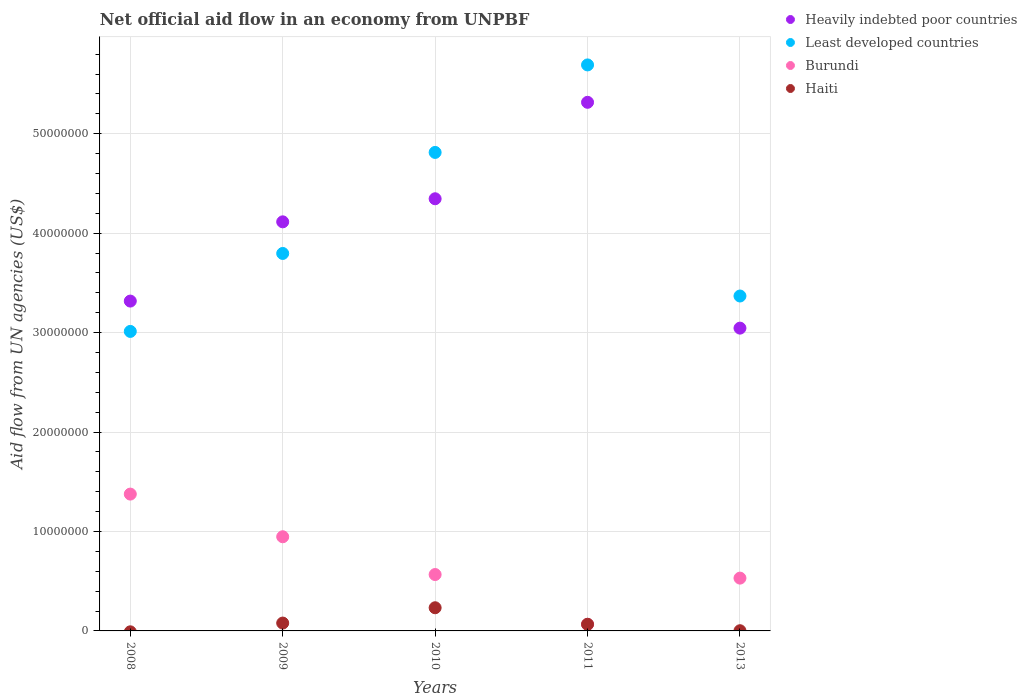How many different coloured dotlines are there?
Provide a short and direct response. 4. Is the number of dotlines equal to the number of legend labels?
Offer a terse response. No. What is the net official aid flow in Least developed countries in 2010?
Make the answer very short. 4.81e+07. Across all years, what is the maximum net official aid flow in Heavily indebted poor countries?
Ensure brevity in your answer.  5.32e+07. Across all years, what is the minimum net official aid flow in Heavily indebted poor countries?
Your response must be concise. 3.04e+07. What is the total net official aid flow in Burundi in the graph?
Make the answer very short. 3.49e+07. What is the difference between the net official aid flow in Least developed countries in 2010 and that in 2013?
Provide a succinct answer. 1.44e+07. What is the difference between the net official aid flow in Least developed countries in 2013 and the net official aid flow in Heavily indebted poor countries in 2009?
Your answer should be very brief. -7.46e+06. What is the average net official aid flow in Burundi per year?
Your answer should be compact. 6.97e+06. In the year 2009, what is the difference between the net official aid flow in Least developed countries and net official aid flow in Heavily indebted poor countries?
Keep it short and to the point. -3.18e+06. What is the ratio of the net official aid flow in Heavily indebted poor countries in 2010 to that in 2013?
Make the answer very short. 1.43. What is the difference between the highest and the second highest net official aid flow in Heavily indebted poor countries?
Give a very brief answer. 9.70e+06. What is the difference between the highest and the lowest net official aid flow in Haiti?
Your answer should be compact. 2.33e+06. Is it the case that in every year, the sum of the net official aid flow in Haiti and net official aid flow in Heavily indebted poor countries  is greater than the net official aid flow in Burundi?
Offer a terse response. Yes. Does the net official aid flow in Haiti monotonically increase over the years?
Offer a very short reply. No. How many years are there in the graph?
Your answer should be very brief. 5. Are the values on the major ticks of Y-axis written in scientific E-notation?
Make the answer very short. No. Does the graph contain any zero values?
Your answer should be very brief. Yes. Does the graph contain grids?
Your answer should be compact. Yes. How are the legend labels stacked?
Keep it short and to the point. Vertical. What is the title of the graph?
Keep it short and to the point. Net official aid flow in an economy from UNPBF. Does "Uganda" appear as one of the legend labels in the graph?
Your answer should be compact. No. What is the label or title of the Y-axis?
Give a very brief answer. Aid flow from UN agencies (US$). What is the Aid flow from UN agencies (US$) in Heavily indebted poor countries in 2008?
Give a very brief answer. 3.32e+07. What is the Aid flow from UN agencies (US$) in Least developed countries in 2008?
Provide a short and direct response. 3.01e+07. What is the Aid flow from UN agencies (US$) of Burundi in 2008?
Provide a succinct answer. 1.38e+07. What is the Aid flow from UN agencies (US$) of Heavily indebted poor countries in 2009?
Keep it short and to the point. 4.11e+07. What is the Aid flow from UN agencies (US$) in Least developed countries in 2009?
Keep it short and to the point. 3.80e+07. What is the Aid flow from UN agencies (US$) of Burundi in 2009?
Your answer should be compact. 9.47e+06. What is the Aid flow from UN agencies (US$) of Haiti in 2009?
Offer a terse response. 7.90e+05. What is the Aid flow from UN agencies (US$) in Heavily indebted poor countries in 2010?
Provide a short and direct response. 4.35e+07. What is the Aid flow from UN agencies (US$) in Least developed countries in 2010?
Your answer should be very brief. 4.81e+07. What is the Aid flow from UN agencies (US$) of Burundi in 2010?
Make the answer very short. 5.67e+06. What is the Aid flow from UN agencies (US$) in Haiti in 2010?
Give a very brief answer. 2.33e+06. What is the Aid flow from UN agencies (US$) in Heavily indebted poor countries in 2011?
Your answer should be very brief. 5.32e+07. What is the Aid flow from UN agencies (US$) of Least developed countries in 2011?
Your answer should be compact. 5.69e+07. What is the Aid flow from UN agencies (US$) in Burundi in 2011?
Keep it short and to the point. 6.60e+05. What is the Aid flow from UN agencies (US$) in Haiti in 2011?
Your answer should be very brief. 6.70e+05. What is the Aid flow from UN agencies (US$) of Heavily indebted poor countries in 2013?
Your answer should be very brief. 3.04e+07. What is the Aid flow from UN agencies (US$) of Least developed countries in 2013?
Give a very brief answer. 3.37e+07. What is the Aid flow from UN agencies (US$) in Burundi in 2013?
Your answer should be very brief. 5.31e+06. Across all years, what is the maximum Aid flow from UN agencies (US$) of Heavily indebted poor countries?
Your answer should be compact. 5.32e+07. Across all years, what is the maximum Aid flow from UN agencies (US$) in Least developed countries?
Your answer should be very brief. 5.69e+07. Across all years, what is the maximum Aid flow from UN agencies (US$) of Burundi?
Offer a terse response. 1.38e+07. Across all years, what is the maximum Aid flow from UN agencies (US$) in Haiti?
Offer a terse response. 2.33e+06. Across all years, what is the minimum Aid flow from UN agencies (US$) in Heavily indebted poor countries?
Offer a very short reply. 3.04e+07. Across all years, what is the minimum Aid flow from UN agencies (US$) in Least developed countries?
Your answer should be compact. 3.01e+07. Across all years, what is the minimum Aid flow from UN agencies (US$) of Burundi?
Your answer should be very brief. 6.60e+05. What is the total Aid flow from UN agencies (US$) of Heavily indebted poor countries in the graph?
Your answer should be very brief. 2.01e+08. What is the total Aid flow from UN agencies (US$) of Least developed countries in the graph?
Give a very brief answer. 2.07e+08. What is the total Aid flow from UN agencies (US$) in Burundi in the graph?
Your answer should be compact. 3.49e+07. What is the total Aid flow from UN agencies (US$) in Haiti in the graph?
Provide a short and direct response. 3.81e+06. What is the difference between the Aid flow from UN agencies (US$) of Heavily indebted poor countries in 2008 and that in 2009?
Give a very brief answer. -7.97e+06. What is the difference between the Aid flow from UN agencies (US$) of Least developed countries in 2008 and that in 2009?
Your answer should be compact. -7.84e+06. What is the difference between the Aid flow from UN agencies (US$) in Burundi in 2008 and that in 2009?
Your answer should be compact. 4.29e+06. What is the difference between the Aid flow from UN agencies (US$) in Heavily indebted poor countries in 2008 and that in 2010?
Provide a succinct answer. -1.03e+07. What is the difference between the Aid flow from UN agencies (US$) in Least developed countries in 2008 and that in 2010?
Make the answer very short. -1.80e+07. What is the difference between the Aid flow from UN agencies (US$) of Burundi in 2008 and that in 2010?
Give a very brief answer. 8.09e+06. What is the difference between the Aid flow from UN agencies (US$) in Heavily indebted poor countries in 2008 and that in 2011?
Offer a terse response. -2.00e+07. What is the difference between the Aid flow from UN agencies (US$) in Least developed countries in 2008 and that in 2011?
Offer a very short reply. -2.68e+07. What is the difference between the Aid flow from UN agencies (US$) of Burundi in 2008 and that in 2011?
Your response must be concise. 1.31e+07. What is the difference between the Aid flow from UN agencies (US$) of Heavily indebted poor countries in 2008 and that in 2013?
Offer a very short reply. 2.72e+06. What is the difference between the Aid flow from UN agencies (US$) in Least developed countries in 2008 and that in 2013?
Offer a terse response. -3.56e+06. What is the difference between the Aid flow from UN agencies (US$) in Burundi in 2008 and that in 2013?
Your response must be concise. 8.45e+06. What is the difference between the Aid flow from UN agencies (US$) of Heavily indebted poor countries in 2009 and that in 2010?
Offer a very short reply. -2.32e+06. What is the difference between the Aid flow from UN agencies (US$) of Least developed countries in 2009 and that in 2010?
Ensure brevity in your answer.  -1.02e+07. What is the difference between the Aid flow from UN agencies (US$) of Burundi in 2009 and that in 2010?
Provide a short and direct response. 3.80e+06. What is the difference between the Aid flow from UN agencies (US$) in Haiti in 2009 and that in 2010?
Give a very brief answer. -1.54e+06. What is the difference between the Aid flow from UN agencies (US$) of Heavily indebted poor countries in 2009 and that in 2011?
Ensure brevity in your answer.  -1.20e+07. What is the difference between the Aid flow from UN agencies (US$) in Least developed countries in 2009 and that in 2011?
Provide a succinct answer. -1.90e+07. What is the difference between the Aid flow from UN agencies (US$) of Burundi in 2009 and that in 2011?
Make the answer very short. 8.81e+06. What is the difference between the Aid flow from UN agencies (US$) of Haiti in 2009 and that in 2011?
Your answer should be compact. 1.20e+05. What is the difference between the Aid flow from UN agencies (US$) of Heavily indebted poor countries in 2009 and that in 2013?
Make the answer very short. 1.07e+07. What is the difference between the Aid flow from UN agencies (US$) in Least developed countries in 2009 and that in 2013?
Your answer should be compact. 4.28e+06. What is the difference between the Aid flow from UN agencies (US$) of Burundi in 2009 and that in 2013?
Provide a succinct answer. 4.16e+06. What is the difference between the Aid flow from UN agencies (US$) of Haiti in 2009 and that in 2013?
Make the answer very short. 7.70e+05. What is the difference between the Aid flow from UN agencies (US$) of Heavily indebted poor countries in 2010 and that in 2011?
Ensure brevity in your answer.  -9.70e+06. What is the difference between the Aid flow from UN agencies (US$) in Least developed countries in 2010 and that in 2011?
Provide a short and direct response. -8.80e+06. What is the difference between the Aid flow from UN agencies (US$) in Burundi in 2010 and that in 2011?
Provide a succinct answer. 5.01e+06. What is the difference between the Aid flow from UN agencies (US$) of Haiti in 2010 and that in 2011?
Your response must be concise. 1.66e+06. What is the difference between the Aid flow from UN agencies (US$) of Heavily indebted poor countries in 2010 and that in 2013?
Keep it short and to the point. 1.30e+07. What is the difference between the Aid flow from UN agencies (US$) in Least developed countries in 2010 and that in 2013?
Your response must be concise. 1.44e+07. What is the difference between the Aid flow from UN agencies (US$) in Burundi in 2010 and that in 2013?
Provide a succinct answer. 3.60e+05. What is the difference between the Aid flow from UN agencies (US$) in Haiti in 2010 and that in 2013?
Ensure brevity in your answer.  2.31e+06. What is the difference between the Aid flow from UN agencies (US$) of Heavily indebted poor countries in 2011 and that in 2013?
Make the answer very short. 2.27e+07. What is the difference between the Aid flow from UN agencies (US$) of Least developed countries in 2011 and that in 2013?
Provide a succinct answer. 2.32e+07. What is the difference between the Aid flow from UN agencies (US$) of Burundi in 2011 and that in 2013?
Make the answer very short. -4.65e+06. What is the difference between the Aid flow from UN agencies (US$) of Haiti in 2011 and that in 2013?
Your answer should be very brief. 6.50e+05. What is the difference between the Aid flow from UN agencies (US$) of Heavily indebted poor countries in 2008 and the Aid flow from UN agencies (US$) of Least developed countries in 2009?
Your response must be concise. -4.79e+06. What is the difference between the Aid flow from UN agencies (US$) of Heavily indebted poor countries in 2008 and the Aid flow from UN agencies (US$) of Burundi in 2009?
Make the answer very short. 2.37e+07. What is the difference between the Aid flow from UN agencies (US$) in Heavily indebted poor countries in 2008 and the Aid flow from UN agencies (US$) in Haiti in 2009?
Give a very brief answer. 3.24e+07. What is the difference between the Aid flow from UN agencies (US$) in Least developed countries in 2008 and the Aid flow from UN agencies (US$) in Burundi in 2009?
Your answer should be compact. 2.06e+07. What is the difference between the Aid flow from UN agencies (US$) in Least developed countries in 2008 and the Aid flow from UN agencies (US$) in Haiti in 2009?
Your answer should be compact. 2.93e+07. What is the difference between the Aid flow from UN agencies (US$) in Burundi in 2008 and the Aid flow from UN agencies (US$) in Haiti in 2009?
Give a very brief answer. 1.30e+07. What is the difference between the Aid flow from UN agencies (US$) in Heavily indebted poor countries in 2008 and the Aid flow from UN agencies (US$) in Least developed countries in 2010?
Provide a short and direct response. -1.50e+07. What is the difference between the Aid flow from UN agencies (US$) in Heavily indebted poor countries in 2008 and the Aid flow from UN agencies (US$) in Burundi in 2010?
Provide a short and direct response. 2.75e+07. What is the difference between the Aid flow from UN agencies (US$) in Heavily indebted poor countries in 2008 and the Aid flow from UN agencies (US$) in Haiti in 2010?
Ensure brevity in your answer.  3.08e+07. What is the difference between the Aid flow from UN agencies (US$) of Least developed countries in 2008 and the Aid flow from UN agencies (US$) of Burundi in 2010?
Give a very brief answer. 2.44e+07. What is the difference between the Aid flow from UN agencies (US$) in Least developed countries in 2008 and the Aid flow from UN agencies (US$) in Haiti in 2010?
Keep it short and to the point. 2.78e+07. What is the difference between the Aid flow from UN agencies (US$) of Burundi in 2008 and the Aid flow from UN agencies (US$) of Haiti in 2010?
Provide a short and direct response. 1.14e+07. What is the difference between the Aid flow from UN agencies (US$) of Heavily indebted poor countries in 2008 and the Aid flow from UN agencies (US$) of Least developed countries in 2011?
Your answer should be compact. -2.38e+07. What is the difference between the Aid flow from UN agencies (US$) in Heavily indebted poor countries in 2008 and the Aid flow from UN agencies (US$) in Burundi in 2011?
Your response must be concise. 3.25e+07. What is the difference between the Aid flow from UN agencies (US$) of Heavily indebted poor countries in 2008 and the Aid flow from UN agencies (US$) of Haiti in 2011?
Provide a short and direct response. 3.25e+07. What is the difference between the Aid flow from UN agencies (US$) of Least developed countries in 2008 and the Aid flow from UN agencies (US$) of Burundi in 2011?
Your answer should be very brief. 2.95e+07. What is the difference between the Aid flow from UN agencies (US$) of Least developed countries in 2008 and the Aid flow from UN agencies (US$) of Haiti in 2011?
Your response must be concise. 2.94e+07. What is the difference between the Aid flow from UN agencies (US$) of Burundi in 2008 and the Aid flow from UN agencies (US$) of Haiti in 2011?
Ensure brevity in your answer.  1.31e+07. What is the difference between the Aid flow from UN agencies (US$) of Heavily indebted poor countries in 2008 and the Aid flow from UN agencies (US$) of Least developed countries in 2013?
Your answer should be very brief. -5.10e+05. What is the difference between the Aid flow from UN agencies (US$) in Heavily indebted poor countries in 2008 and the Aid flow from UN agencies (US$) in Burundi in 2013?
Make the answer very short. 2.79e+07. What is the difference between the Aid flow from UN agencies (US$) of Heavily indebted poor countries in 2008 and the Aid flow from UN agencies (US$) of Haiti in 2013?
Keep it short and to the point. 3.32e+07. What is the difference between the Aid flow from UN agencies (US$) in Least developed countries in 2008 and the Aid flow from UN agencies (US$) in Burundi in 2013?
Your answer should be very brief. 2.48e+07. What is the difference between the Aid flow from UN agencies (US$) of Least developed countries in 2008 and the Aid flow from UN agencies (US$) of Haiti in 2013?
Offer a terse response. 3.01e+07. What is the difference between the Aid flow from UN agencies (US$) of Burundi in 2008 and the Aid flow from UN agencies (US$) of Haiti in 2013?
Offer a very short reply. 1.37e+07. What is the difference between the Aid flow from UN agencies (US$) in Heavily indebted poor countries in 2009 and the Aid flow from UN agencies (US$) in Least developed countries in 2010?
Ensure brevity in your answer.  -6.98e+06. What is the difference between the Aid flow from UN agencies (US$) of Heavily indebted poor countries in 2009 and the Aid flow from UN agencies (US$) of Burundi in 2010?
Provide a succinct answer. 3.55e+07. What is the difference between the Aid flow from UN agencies (US$) in Heavily indebted poor countries in 2009 and the Aid flow from UN agencies (US$) in Haiti in 2010?
Offer a very short reply. 3.88e+07. What is the difference between the Aid flow from UN agencies (US$) of Least developed countries in 2009 and the Aid flow from UN agencies (US$) of Burundi in 2010?
Make the answer very short. 3.23e+07. What is the difference between the Aid flow from UN agencies (US$) in Least developed countries in 2009 and the Aid flow from UN agencies (US$) in Haiti in 2010?
Provide a succinct answer. 3.56e+07. What is the difference between the Aid flow from UN agencies (US$) of Burundi in 2009 and the Aid flow from UN agencies (US$) of Haiti in 2010?
Make the answer very short. 7.14e+06. What is the difference between the Aid flow from UN agencies (US$) of Heavily indebted poor countries in 2009 and the Aid flow from UN agencies (US$) of Least developed countries in 2011?
Make the answer very short. -1.58e+07. What is the difference between the Aid flow from UN agencies (US$) of Heavily indebted poor countries in 2009 and the Aid flow from UN agencies (US$) of Burundi in 2011?
Make the answer very short. 4.05e+07. What is the difference between the Aid flow from UN agencies (US$) of Heavily indebted poor countries in 2009 and the Aid flow from UN agencies (US$) of Haiti in 2011?
Offer a terse response. 4.05e+07. What is the difference between the Aid flow from UN agencies (US$) of Least developed countries in 2009 and the Aid flow from UN agencies (US$) of Burundi in 2011?
Keep it short and to the point. 3.73e+07. What is the difference between the Aid flow from UN agencies (US$) of Least developed countries in 2009 and the Aid flow from UN agencies (US$) of Haiti in 2011?
Your answer should be very brief. 3.73e+07. What is the difference between the Aid flow from UN agencies (US$) in Burundi in 2009 and the Aid flow from UN agencies (US$) in Haiti in 2011?
Offer a very short reply. 8.80e+06. What is the difference between the Aid flow from UN agencies (US$) of Heavily indebted poor countries in 2009 and the Aid flow from UN agencies (US$) of Least developed countries in 2013?
Your answer should be very brief. 7.46e+06. What is the difference between the Aid flow from UN agencies (US$) in Heavily indebted poor countries in 2009 and the Aid flow from UN agencies (US$) in Burundi in 2013?
Your answer should be very brief. 3.58e+07. What is the difference between the Aid flow from UN agencies (US$) of Heavily indebted poor countries in 2009 and the Aid flow from UN agencies (US$) of Haiti in 2013?
Keep it short and to the point. 4.11e+07. What is the difference between the Aid flow from UN agencies (US$) of Least developed countries in 2009 and the Aid flow from UN agencies (US$) of Burundi in 2013?
Provide a short and direct response. 3.26e+07. What is the difference between the Aid flow from UN agencies (US$) in Least developed countries in 2009 and the Aid flow from UN agencies (US$) in Haiti in 2013?
Keep it short and to the point. 3.79e+07. What is the difference between the Aid flow from UN agencies (US$) in Burundi in 2009 and the Aid flow from UN agencies (US$) in Haiti in 2013?
Your response must be concise. 9.45e+06. What is the difference between the Aid flow from UN agencies (US$) of Heavily indebted poor countries in 2010 and the Aid flow from UN agencies (US$) of Least developed countries in 2011?
Provide a succinct answer. -1.35e+07. What is the difference between the Aid flow from UN agencies (US$) of Heavily indebted poor countries in 2010 and the Aid flow from UN agencies (US$) of Burundi in 2011?
Your answer should be compact. 4.28e+07. What is the difference between the Aid flow from UN agencies (US$) in Heavily indebted poor countries in 2010 and the Aid flow from UN agencies (US$) in Haiti in 2011?
Your answer should be very brief. 4.28e+07. What is the difference between the Aid flow from UN agencies (US$) of Least developed countries in 2010 and the Aid flow from UN agencies (US$) of Burundi in 2011?
Ensure brevity in your answer.  4.75e+07. What is the difference between the Aid flow from UN agencies (US$) in Least developed countries in 2010 and the Aid flow from UN agencies (US$) in Haiti in 2011?
Offer a very short reply. 4.74e+07. What is the difference between the Aid flow from UN agencies (US$) of Heavily indebted poor countries in 2010 and the Aid flow from UN agencies (US$) of Least developed countries in 2013?
Ensure brevity in your answer.  9.78e+06. What is the difference between the Aid flow from UN agencies (US$) of Heavily indebted poor countries in 2010 and the Aid flow from UN agencies (US$) of Burundi in 2013?
Provide a succinct answer. 3.82e+07. What is the difference between the Aid flow from UN agencies (US$) of Heavily indebted poor countries in 2010 and the Aid flow from UN agencies (US$) of Haiti in 2013?
Your answer should be compact. 4.34e+07. What is the difference between the Aid flow from UN agencies (US$) of Least developed countries in 2010 and the Aid flow from UN agencies (US$) of Burundi in 2013?
Provide a short and direct response. 4.28e+07. What is the difference between the Aid flow from UN agencies (US$) of Least developed countries in 2010 and the Aid flow from UN agencies (US$) of Haiti in 2013?
Keep it short and to the point. 4.81e+07. What is the difference between the Aid flow from UN agencies (US$) of Burundi in 2010 and the Aid flow from UN agencies (US$) of Haiti in 2013?
Offer a very short reply. 5.65e+06. What is the difference between the Aid flow from UN agencies (US$) of Heavily indebted poor countries in 2011 and the Aid flow from UN agencies (US$) of Least developed countries in 2013?
Provide a short and direct response. 1.95e+07. What is the difference between the Aid flow from UN agencies (US$) of Heavily indebted poor countries in 2011 and the Aid flow from UN agencies (US$) of Burundi in 2013?
Give a very brief answer. 4.78e+07. What is the difference between the Aid flow from UN agencies (US$) of Heavily indebted poor countries in 2011 and the Aid flow from UN agencies (US$) of Haiti in 2013?
Offer a terse response. 5.31e+07. What is the difference between the Aid flow from UN agencies (US$) in Least developed countries in 2011 and the Aid flow from UN agencies (US$) in Burundi in 2013?
Your answer should be very brief. 5.16e+07. What is the difference between the Aid flow from UN agencies (US$) in Least developed countries in 2011 and the Aid flow from UN agencies (US$) in Haiti in 2013?
Offer a terse response. 5.69e+07. What is the difference between the Aid flow from UN agencies (US$) in Burundi in 2011 and the Aid flow from UN agencies (US$) in Haiti in 2013?
Ensure brevity in your answer.  6.40e+05. What is the average Aid flow from UN agencies (US$) in Heavily indebted poor countries per year?
Provide a short and direct response. 4.03e+07. What is the average Aid flow from UN agencies (US$) of Least developed countries per year?
Give a very brief answer. 4.14e+07. What is the average Aid flow from UN agencies (US$) of Burundi per year?
Give a very brief answer. 6.97e+06. What is the average Aid flow from UN agencies (US$) of Haiti per year?
Ensure brevity in your answer.  7.62e+05. In the year 2008, what is the difference between the Aid flow from UN agencies (US$) of Heavily indebted poor countries and Aid flow from UN agencies (US$) of Least developed countries?
Your response must be concise. 3.05e+06. In the year 2008, what is the difference between the Aid flow from UN agencies (US$) of Heavily indebted poor countries and Aid flow from UN agencies (US$) of Burundi?
Your answer should be compact. 1.94e+07. In the year 2008, what is the difference between the Aid flow from UN agencies (US$) of Least developed countries and Aid flow from UN agencies (US$) of Burundi?
Ensure brevity in your answer.  1.64e+07. In the year 2009, what is the difference between the Aid flow from UN agencies (US$) of Heavily indebted poor countries and Aid flow from UN agencies (US$) of Least developed countries?
Make the answer very short. 3.18e+06. In the year 2009, what is the difference between the Aid flow from UN agencies (US$) in Heavily indebted poor countries and Aid flow from UN agencies (US$) in Burundi?
Offer a very short reply. 3.17e+07. In the year 2009, what is the difference between the Aid flow from UN agencies (US$) in Heavily indebted poor countries and Aid flow from UN agencies (US$) in Haiti?
Keep it short and to the point. 4.04e+07. In the year 2009, what is the difference between the Aid flow from UN agencies (US$) of Least developed countries and Aid flow from UN agencies (US$) of Burundi?
Keep it short and to the point. 2.85e+07. In the year 2009, what is the difference between the Aid flow from UN agencies (US$) in Least developed countries and Aid flow from UN agencies (US$) in Haiti?
Your answer should be compact. 3.72e+07. In the year 2009, what is the difference between the Aid flow from UN agencies (US$) of Burundi and Aid flow from UN agencies (US$) of Haiti?
Provide a short and direct response. 8.68e+06. In the year 2010, what is the difference between the Aid flow from UN agencies (US$) in Heavily indebted poor countries and Aid flow from UN agencies (US$) in Least developed countries?
Your answer should be compact. -4.66e+06. In the year 2010, what is the difference between the Aid flow from UN agencies (US$) of Heavily indebted poor countries and Aid flow from UN agencies (US$) of Burundi?
Keep it short and to the point. 3.78e+07. In the year 2010, what is the difference between the Aid flow from UN agencies (US$) in Heavily indebted poor countries and Aid flow from UN agencies (US$) in Haiti?
Give a very brief answer. 4.11e+07. In the year 2010, what is the difference between the Aid flow from UN agencies (US$) in Least developed countries and Aid flow from UN agencies (US$) in Burundi?
Give a very brief answer. 4.24e+07. In the year 2010, what is the difference between the Aid flow from UN agencies (US$) of Least developed countries and Aid flow from UN agencies (US$) of Haiti?
Offer a very short reply. 4.58e+07. In the year 2010, what is the difference between the Aid flow from UN agencies (US$) of Burundi and Aid flow from UN agencies (US$) of Haiti?
Ensure brevity in your answer.  3.34e+06. In the year 2011, what is the difference between the Aid flow from UN agencies (US$) in Heavily indebted poor countries and Aid flow from UN agencies (US$) in Least developed countries?
Provide a short and direct response. -3.76e+06. In the year 2011, what is the difference between the Aid flow from UN agencies (US$) of Heavily indebted poor countries and Aid flow from UN agencies (US$) of Burundi?
Your answer should be very brief. 5.25e+07. In the year 2011, what is the difference between the Aid flow from UN agencies (US$) of Heavily indebted poor countries and Aid flow from UN agencies (US$) of Haiti?
Your response must be concise. 5.25e+07. In the year 2011, what is the difference between the Aid flow from UN agencies (US$) of Least developed countries and Aid flow from UN agencies (US$) of Burundi?
Offer a very short reply. 5.63e+07. In the year 2011, what is the difference between the Aid flow from UN agencies (US$) in Least developed countries and Aid flow from UN agencies (US$) in Haiti?
Ensure brevity in your answer.  5.62e+07. In the year 2011, what is the difference between the Aid flow from UN agencies (US$) of Burundi and Aid flow from UN agencies (US$) of Haiti?
Offer a very short reply. -10000. In the year 2013, what is the difference between the Aid flow from UN agencies (US$) in Heavily indebted poor countries and Aid flow from UN agencies (US$) in Least developed countries?
Make the answer very short. -3.23e+06. In the year 2013, what is the difference between the Aid flow from UN agencies (US$) in Heavily indebted poor countries and Aid flow from UN agencies (US$) in Burundi?
Provide a short and direct response. 2.51e+07. In the year 2013, what is the difference between the Aid flow from UN agencies (US$) of Heavily indebted poor countries and Aid flow from UN agencies (US$) of Haiti?
Offer a very short reply. 3.04e+07. In the year 2013, what is the difference between the Aid flow from UN agencies (US$) in Least developed countries and Aid flow from UN agencies (US$) in Burundi?
Ensure brevity in your answer.  2.84e+07. In the year 2013, what is the difference between the Aid flow from UN agencies (US$) in Least developed countries and Aid flow from UN agencies (US$) in Haiti?
Make the answer very short. 3.37e+07. In the year 2013, what is the difference between the Aid flow from UN agencies (US$) in Burundi and Aid flow from UN agencies (US$) in Haiti?
Offer a very short reply. 5.29e+06. What is the ratio of the Aid flow from UN agencies (US$) of Heavily indebted poor countries in 2008 to that in 2009?
Give a very brief answer. 0.81. What is the ratio of the Aid flow from UN agencies (US$) of Least developed countries in 2008 to that in 2009?
Provide a succinct answer. 0.79. What is the ratio of the Aid flow from UN agencies (US$) of Burundi in 2008 to that in 2009?
Give a very brief answer. 1.45. What is the ratio of the Aid flow from UN agencies (US$) in Heavily indebted poor countries in 2008 to that in 2010?
Your answer should be compact. 0.76. What is the ratio of the Aid flow from UN agencies (US$) in Least developed countries in 2008 to that in 2010?
Provide a short and direct response. 0.63. What is the ratio of the Aid flow from UN agencies (US$) in Burundi in 2008 to that in 2010?
Your response must be concise. 2.43. What is the ratio of the Aid flow from UN agencies (US$) in Heavily indebted poor countries in 2008 to that in 2011?
Offer a very short reply. 0.62. What is the ratio of the Aid flow from UN agencies (US$) in Least developed countries in 2008 to that in 2011?
Offer a very short reply. 0.53. What is the ratio of the Aid flow from UN agencies (US$) of Burundi in 2008 to that in 2011?
Give a very brief answer. 20.85. What is the ratio of the Aid flow from UN agencies (US$) in Heavily indebted poor countries in 2008 to that in 2013?
Keep it short and to the point. 1.09. What is the ratio of the Aid flow from UN agencies (US$) in Least developed countries in 2008 to that in 2013?
Keep it short and to the point. 0.89. What is the ratio of the Aid flow from UN agencies (US$) of Burundi in 2008 to that in 2013?
Your answer should be compact. 2.59. What is the ratio of the Aid flow from UN agencies (US$) in Heavily indebted poor countries in 2009 to that in 2010?
Offer a terse response. 0.95. What is the ratio of the Aid flow from UN agencies (US$) in Least developed countries in 2009 to that in 2010?
Make the answer very short. 0.79. What is the ratio of the Aid flow from UN agencies (US$) in Burundi in 2009 to that in 2010?
Your response must be concise. 1.67. What is the ratio of the Aid flow from UN agencies (US$) of Haiti in 2009 to that in 2010?
Provide a succinct answer. 0.34. What is the ratio of the Aid flow from UN agencies (US$) of Heavily indebted poor countries in 2009 to that in 2011?
Offer a terse response. 0.77. What is the ratio of the Aid flow from UN agencies (US$) in Least developed countries in 2009 to that in 2011?
Your answer should be compact. 0.67. What is the ratio of the Aid flow from UN agencies (US$) in Burundi in 2009 to that in 2011?
Your response must be concise. 14.35. What is the ratio of the Aid flow from UN agencies (US$) of Haiti in 2009 to that in 2011?
Your response must be concise. 1.18. What is the ratio of the Aid flow from UN agencies (US$) in Heavily indebted poor countries in 2009 to that in 2013?
Your response must be concise. 1.35. What is the ratio of the Aid flow from UN agencies (US$) of Least developed countries in 2009 to that in 2013?
Provide a short and direct response. 1.13. What is the ratio of the Aid flow from UN agencies (US$) in Burundi in 2009 to that in 2013?
Keep it short and to the point. 1.78. What is the ratio of the Aid flow from UN agencies (US$) in Haiti in 2009 to that in 2013?
Provide a short and direct response. 39.5. What is the ratio of the Aid flow from UN agencies (US$) in Heavily indebted poor countries in 2010 to that in 2011?
Your answer should be very brief. 0.82. What is the ratio of the Aid flow from UN agencies (US$) in Least developed countries in 2010 to that in 2011?
Your answer should be very brief. 0.85. What is the ratio of the Aid flow from UN agencies (US$) of Burundi in 2010 to that in 2011?
Your answer should be compact. 8.59. What is the ratio of the Aid flow from UN agencies (US$) in Haiti in 2010 to that in 2011?
Offer a terse response. 3.48. What is the ratio of the Aid flow from UN agencies (US$) in Heavily indebted poor countries in 2010 to that in 2013?
Your response must be concise. 1.43. What is the ratio of the Aid flow from UN agencies (US$) in Least developed countries in 2010 to that in 2013?
Provide a succinct answer. 1.43. What is the ratio of the Aid flow from UN agencies (US$) of Burundi in 2010 to that in 2013?
Provide a short and direct response. 1.07. What is the ratio of the Aid flow from UN agencies (US$) in Haiti in 2010 to that in 2013?
Ensure brevity in your answer.  116.5. What is the ratio of the Aid flow from UN agencies (US$) in Heavily indebted poor countries in 2011 to that in 2013?
Provide a succinct answer. 1.75. What is the ratio of the Aid flow from UN agencies (US$) in Least developed countries in 2011 to that in 2013?
Keep it short and to the point. 1.69. What is the ratio of the Aid flow from UN agencies (US$) in Burundi in 2011 to that in 2013?
Keep it short and to the point. 0.12. What is the ratio of the Aid flow from UN agencies (US$) of Haiti in 2011 to that in 2013?
Provide a short and direct response. 33.5. What is the difference between the highest and the second highest Aid flow from UN agencies (US$) of Heavily indebted poor countries?
Keep it short and to the point. 9.70e+06. What is the difference between the highest and the second highest Aid flow from UN agencies (US$) in Least developed countries?
Your answer should be compact. 8.80e+06. What is the difference between the highest and the second highest Aid flow from UN agencies (US$) of Burundi?
Keep it short and to the point. 4.29e+06. What is the difference between the highest and the second highest Aid flow from UN agencies (US$) of Haiti?
Offer a terse response. 1.54e+06. What is the difference between the highest and the lowest Aid flow from UN agencies (US$) in Heavily indebted poor countries?
Provide a succinct answer. 2.27e+07. What is the difference between the highest and the lowest Aid flow from UN agencies (US$) of Least developed countries?
Keep it short and to the point. 2.68e+07. What is the difference between the highest and the lowest Aid flow from UN agencies (US$) of Burundi?
Provide a short and direct response. 1.31e+07. What is the difference between the highest and the lowest Aid flow from UN agencies (US$) in Haiti?
Your answer should be very brief. 2.33e+06. 